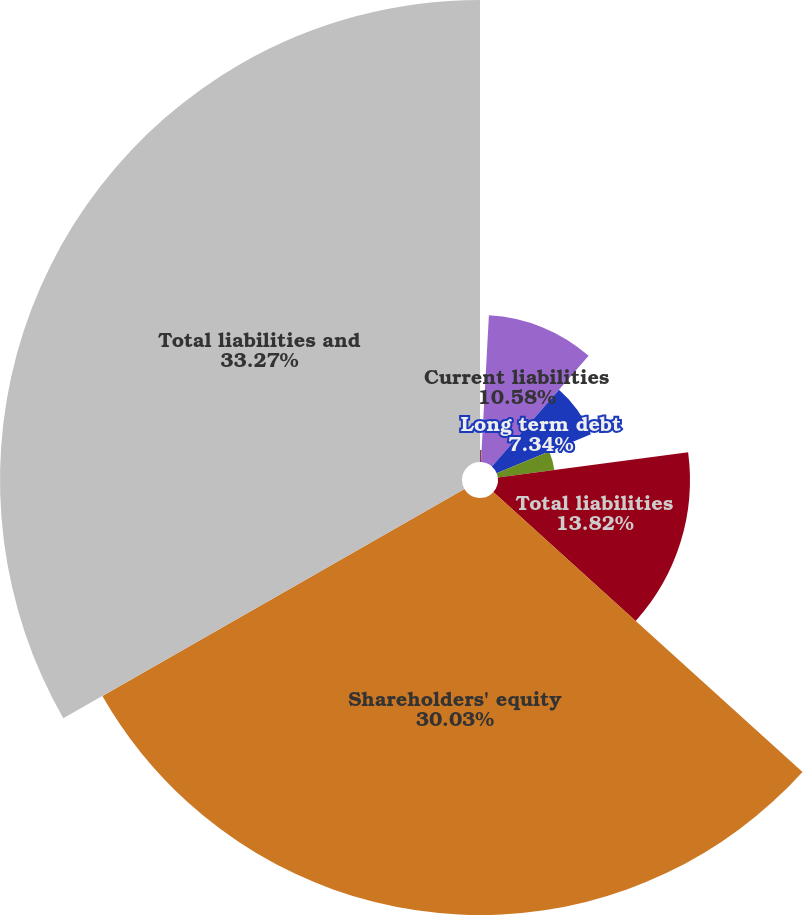<chart> <loc_0><loc_0><loc_500><loc_500><pie_chart><fcel>Accounts payable and accrued<fcel>Current liabilities<fcel>Long term debt<fcel>Deferred income tax and other<fcel>Total liabilities<fcel>Shareholders' equity<fcel>Total liabilities and<nl><fcel>0.86%<fcel>10.58%<fcel>7.34%<fcel>4.1%<fcel>13.82%<fcel>30.02%<fcel>33.26%<nl></chart> 